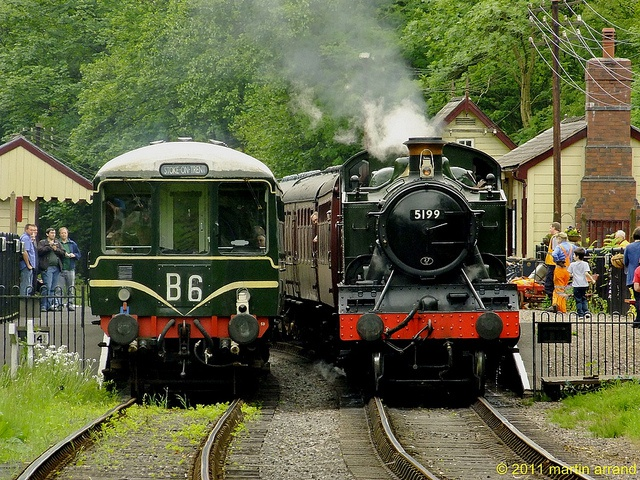Describe the objects in this image and their specific colors. I can see train in olive, black, gray, darkgray, and darkgreen tones, train in olive, black, lightgray, gray, and darkgreen tones, people in olive, black, gray, and blue tones, people in olive, orange, red, black, and darkgray tones, and people in olive, black, lightgray, darkgray, and gray tones in this image. 